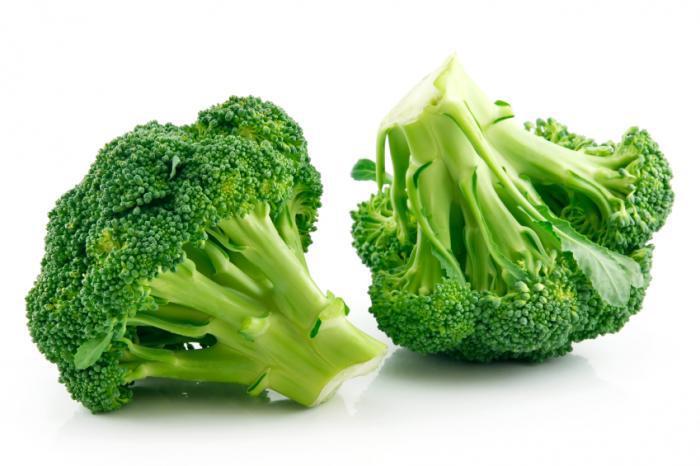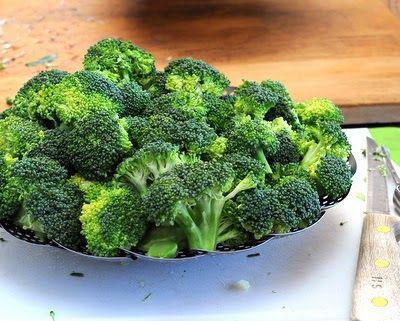The first image is the image on the left, the second image is the image on the right. Analyze the images presented: Is the assertion "In 1 of the images, there is broccoli on a plate." valid? Answer yes or no. Yes. The first image is the image on the left, the second image is the image on the right. For the images displayed, is the sentence "One image shows broccoli florets in a collander shaped like a dish." factually correct? Answer yes or no. Yes. 